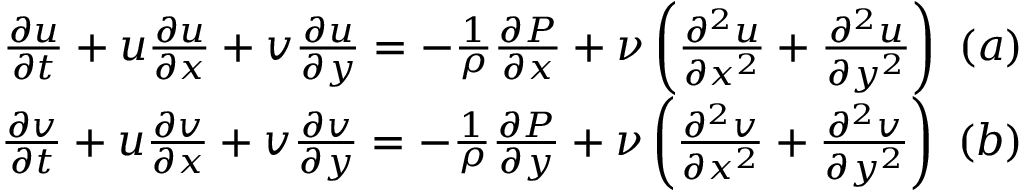<formula> <loc_0><loc_0><loc_500><loc_500>\begin{array} { r } { \frac { \partial u } { \partial t } + u \frac { \partial u } { \partial x } + v \frac { \partial u } { \partial y } = - \frac { 1 } { \rho } \frac { \partial P } { \partial x } + \nu \left ( { \frac { \partial ^ { 2 } u } { \partial x ^ { 2 } } + \frac { \partial ^ { 2 } u } { \partial y ^ { 2 } } } \right ) ( a ) } \\ { \frac { \partial v } { \partial t } + u \frac { \partial v } { \partial x } + v \frac { \partial v } { \partial y } = - \frac { 1 } { \rho } \frac { \partial P } { \partial y } + \nu \left ( { \frac { \partial ^ { 2 } v } { \partial x ^ { 2 } } + \frac { \partial ^ { 2 } v } { \partial y ^ { 2 } } } \right ) ( b ) } \end{array}</formula> 